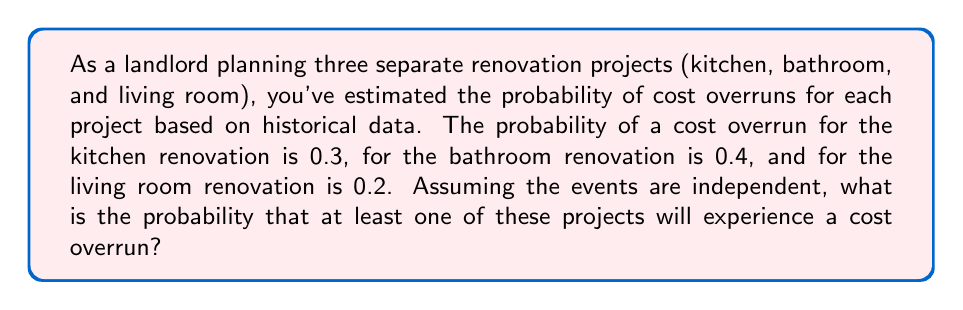What is the answer to this math problem? Let's approach this step-by-step:

1) First, let's define our events:
   K: Kitchen renovation has a cost overrun (P(K) = 0.3)
   B: Bathroom renovation has a cost overrun (P(B) = 0.4)
   L: Living room renovation has a cost overrun (P(L) = 0.2)

2) We want to find the probability that at least one project has a cost overrun. It's easier to calculate the probability of the complement event: no projects have a cost overrun.

3) The probability of no cost overrun for each project:
   P(not K) = 1 - P(K) = 1 - 0.3 = 0.7
   P(not B) = 1 - P(B) = 1 - 0.4 = 0.6
   P(not L) = 1 - P(L) = 1 - 0.2 = 0.8

4) Since the events are independent, we can multiply these probabilities:
   P(no overruns) = P(not K) × P(not B) × P(not L)
                  = 0.7 × 0.6 × 0.8
                  = 0.336

5) Therefore, the probability of at least one overrun is:
   P(at least one overrun) = 1 - P(no overruns)
                            = 1 - 0.336
                            = 0.664

Thus, the probability that at least one project will experience a cost overrun is 0.664 or 66.4%.
Answer: 0.664 